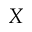Convert formula to latex. <formula><loc_0><loc_0><loc_500><loc_500>X</formula> 